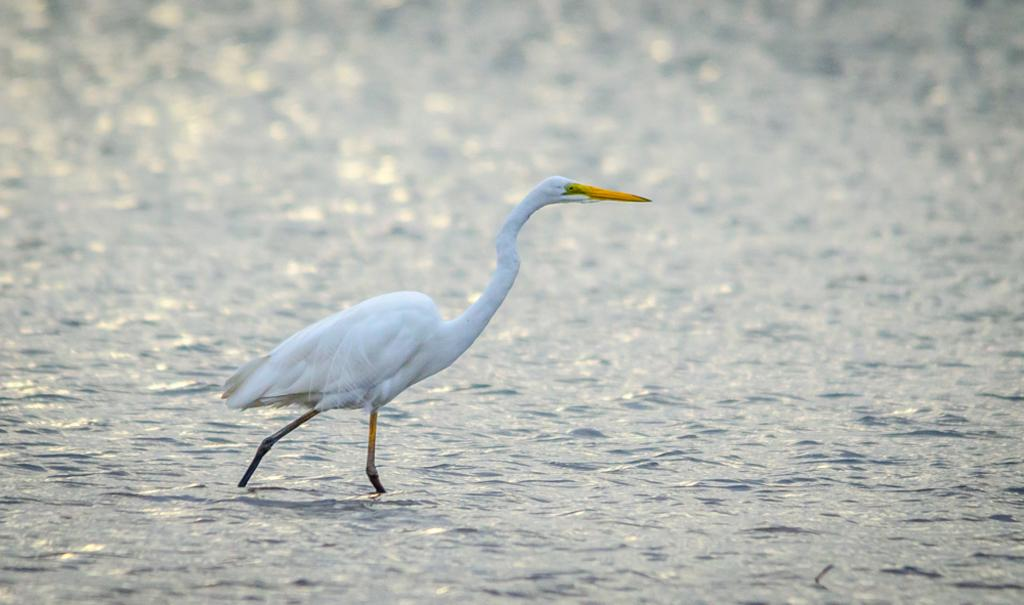What is located in the water in the image? There is a crane in the water in the image. Can you describe the background of the image? The background of the image is blurred. Where are the houses located in the image? There are no houses present in the image. What type of seat can be seen in the image? There is no seat present in the image. Can you describe the porter's uniform in the image? There is no porter present in the image. 